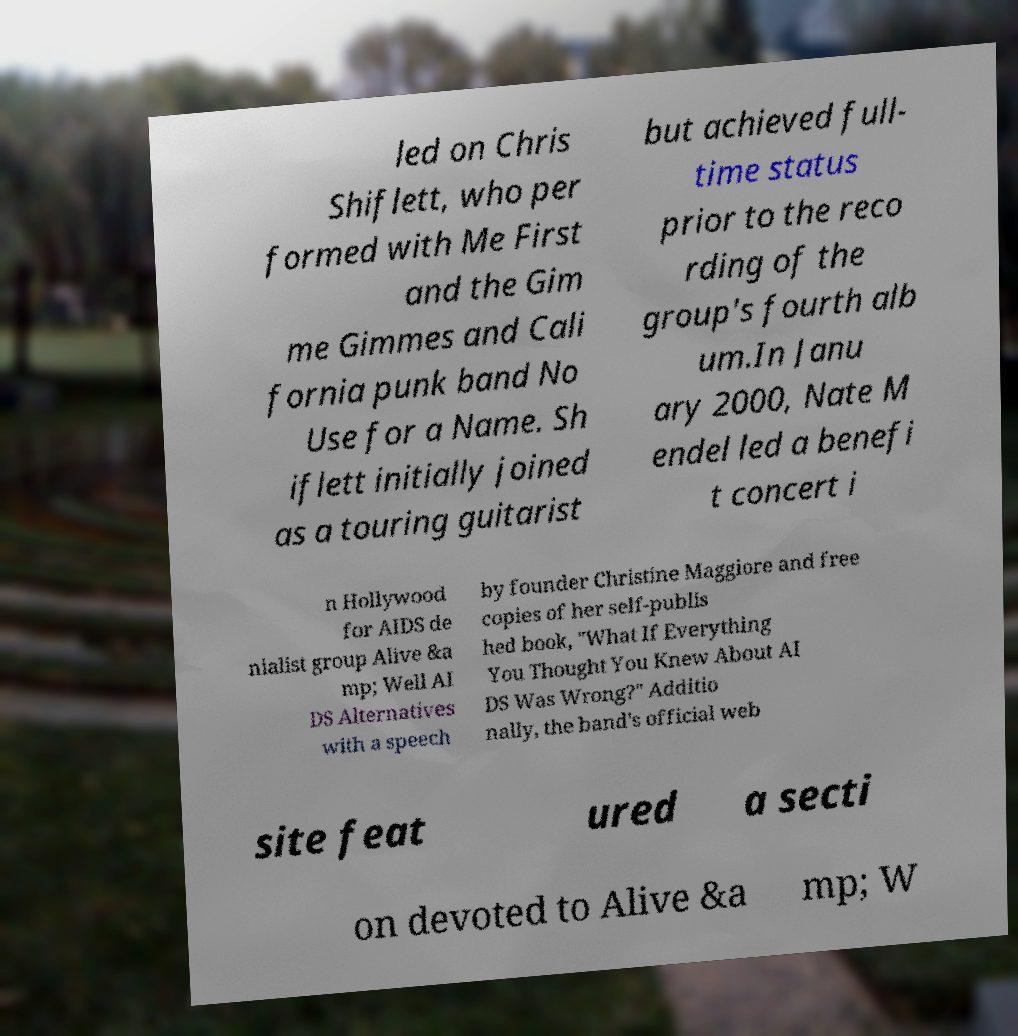Can you read and provide the text displayed in the image?This photo seems to have some interesting text. Can you extract and type it out for me? led on Chris Shiflett, who per formed with Me First and the Gim me Gimmes and Cali fornia punk band No Use for a Name. Sh iflett initially joined as a touring guitarist but achieved full- time status prior to the reco rding of the group's fourth alb um.In Janu ary 2000, Nate M endel led a benefi t concert i n Hollywood for AIDS de nialist group Alive &a mp; Well AI DS Alternatives with a speech by founder Christine Maggiore and free copies of her self-publis hed book, "What If Everything You Thought You Knew About AI DS Was Wrong?" Additio nally, the band's official web site feat ured a secti on devoted to Alive &a mp; W 